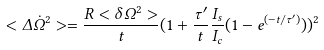Convert formula to latex. <formula><loc_0><loc_0><loc_500><loc_500>< \Delta \dot { \Omega } ^ { 2 } > = \frac { R < \delta \Omega ^ { 2 } > } { t } ( 1 + \frac { \tau ^ { \prime } } { t } \frac { I _ { s } } { I _ { c } } ( 1 - e ^ { ( - t / \tau ^ { \prime } ) } ) ) ^ { 2 }</formula> 